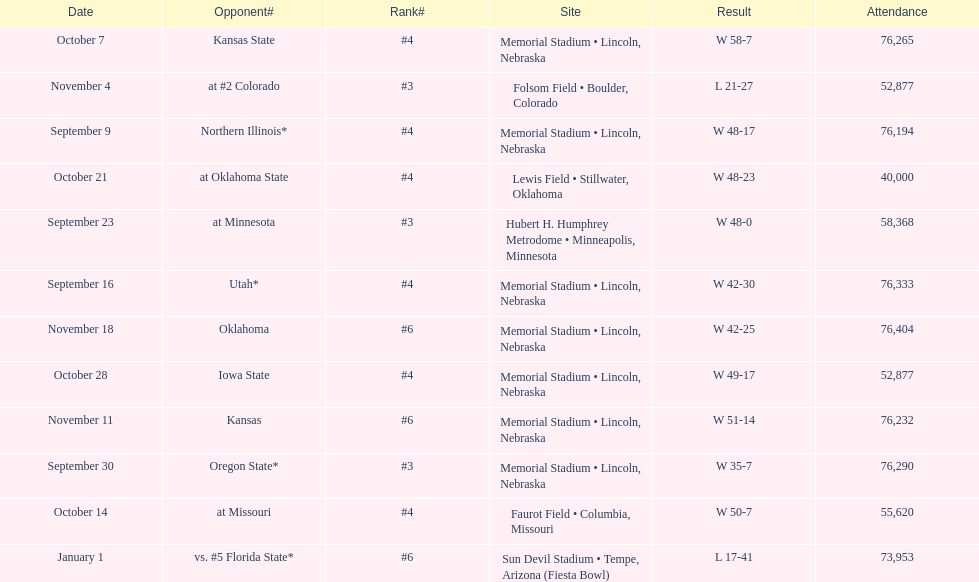What site at most is taken place? Memorial Stadium • Lincoln, Nebraska. 